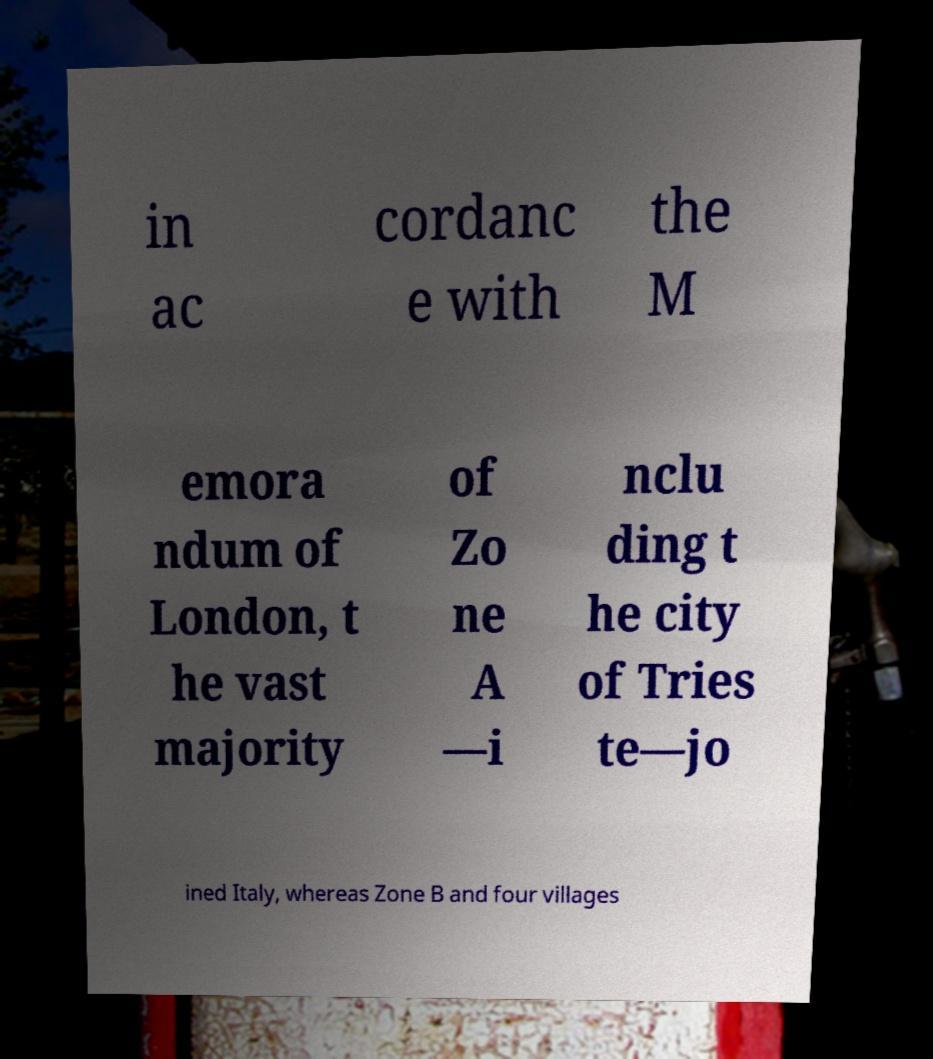What messages or text are displayed in this image? I need them in a readable, typed format. in ac cordanc e with the M emora ndum of London, t he vast majority of Zo ne A —i nclu ding t he city of Tries te—jo ined Italy, whereas Zone B and four villages 